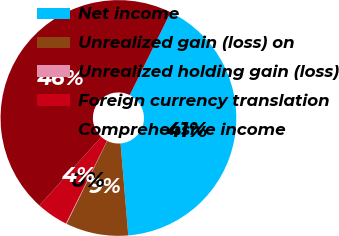Convert chart. <chart><loc_0><loc_0><loc_500><loc_500><pie_chart><fcel>Net income<fcel>Unrealized gain (loss) on<fcel>Unrealized holding gain (loss)<fcel>Foreign currency translation<fcel>Comprehensive income<nl><fcel>41.37%<fcel>8.59%<fcel>0.09%<fcel>4.34%<fcel>45.61%<nl></chart> 